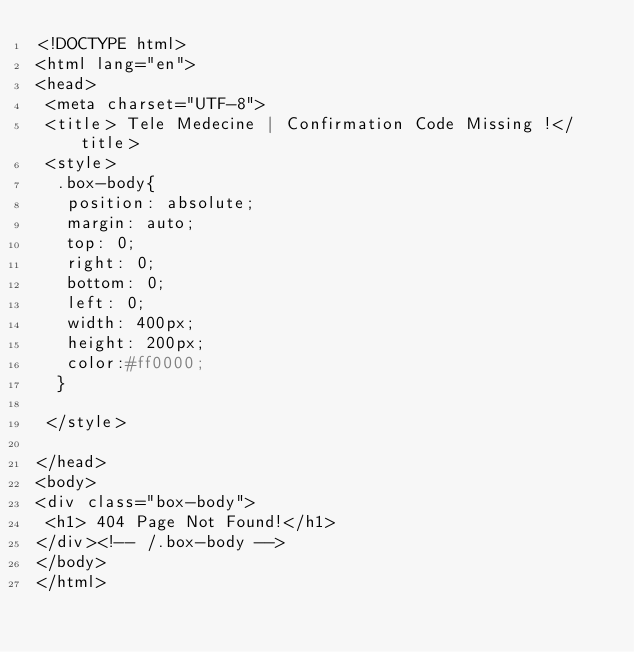<code> <loc_0><loc_0><loc_500><loc_500><_PHP_><!DOCTYPE html>
<html lang="en">
<head>
 <meta charset="UTF-8">
 <title> Tele Medecine | Confirmation Code Missing !</title>
 <style>
  .box-body{
   position: absolute;
   margin: auto;
   top: 0;
   right: 0;
   bottom: 0;
   left: 0;
   width: 400px;
   height: 200px;
   color:#ff0000;
  }

 </style>

</head>
<body>
<div class="box-body">
 <h1> 404 Page Not Found!</h1>
</div><!-- /.box-body -->
</body>
</html></code> 